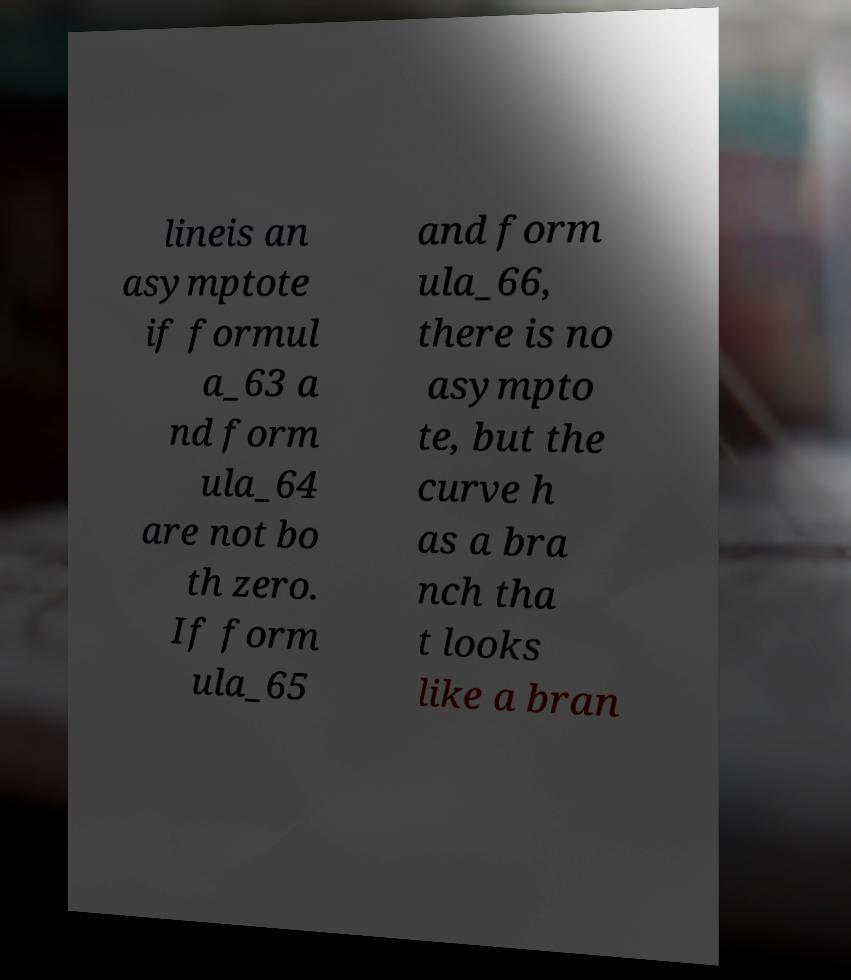Can you accurately transcribe the text from the provided image for me? lineis an asymptote if formul a_63 a nd form ula_64 are not bo th zero. If form ula_65 and form ula_66, there is no asympto te, but the curve h as a bra nch tha t looks like a bran 